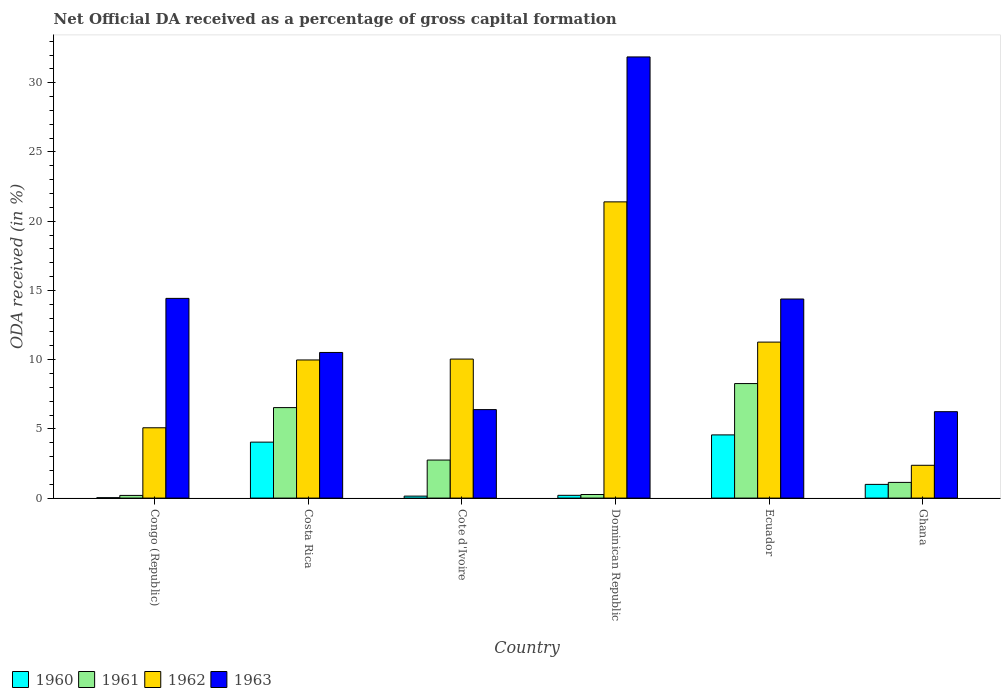Are the number of bars per tick equal to the number of legend labels?
Offer a terse response. Yes. What is the label of the 5th group of bars from the left?
Provide a succinct answer. Ecuador. What is the net ODA received in 1961 in Dominican Republic?
Ensure brevity in your answer.  0.26. Across all countries, what is the maximum net ODA received in 1963?
Provide a succinct answer. 31.86. Across all countries, what is the minimum net ODA received in 1963?
Give a very brief answer. 6.24. In which country was the net ODA received in 1960 maximum?
Your answer should be compact. Ecuador. What is the total net ODA received in 1963 in the graph?
Provide a succinct answer. 83.82. What is the difference between the net ODA received in 1963 in Congo (Republic) and that in Cote d'Ivoire?
Your answer should be very brief. 8.03. What is the difference between the net ODA received in 1960 in Ecuador and the net ODA received in 1963 in Cote d'Ivoire?
Offer a terse response. -1.83. What is the average net ODA received in 1963 per country?
Ensure brevity in your answer.  13.97. What is the difference between the net ODA received of/in 1961 and net ODA received of/in 1962 in Congo (Republic)?
Keep it short and to the point. -4.89. In how many countries, is the net ODA received in 1960 greater than 29 %?
Make the answer very short. 0. What is the ratio of the net ODA received in 1960 in Congo (Republic) to that in Ghana?
Your response must be concise. 0.03. Is the net ODA received in 1963 in Congo (Republic) less than that in Ecuador?
Offer a terse response. No. Is the difference between the net ODA received in 1961 in Congo (Republic) and Ghana greater than the difference between the net ODA received in 1962 in Congo (Republic) and Ghana?
Offer a terse response. No. What is the difference between the highest and the second highest net ODA received in 1962?
Your response must be concise. -1.23. What is the difference between the highest and the lowest net ODA received in 1963?
Offer a terse response. 25.62. Is the sum of the net ODA received in 1962 in Congo (Republic) and Cote d'Ivoire greater than the maximum net ODA received in 1961 across all countries?
Offer a very short reply. Yes. Is it the case that in every country, the sum of the net ODA received in 1962 and net ODA received in 1960 is greater than the sum of net ODA received in 1963 and net ODA received in 1961?
Offer a terse response. No. What does the 3rd bar from the left in Ecuador represents?
Offer a very short reply. 1962. How many bars are there?
Ensure brevity in your answer.  24. Are all the bars in the graph horizontal?
Provide a short and direct response. No. What is the difference between two consecutive major ticks on the Y-axis?
Your response must be concise. 5. Does the graph contain grids?
Make the answer very short. No. What is the title of the graph?
Give a very brief answer. Net Official DA received as a percentage of gross capital formation. Does "1981" appear as one of the legend labels in the graph?
Your response must be concise. No. What is the label or title of the Y-axis?
Give a very brief answer. ODA received (in %). What is the ODA received (in %) of 1960 in Congo (Republic)?
Keep it short and to the point. 0.03. What is the ODA received (in %) of 1961 in Congo (Republic)?
Make the answer very short. 0.19. What is the ODA received (in %) of 1962 in Congo (Republic)?
Ensure brevity in your answer.  5.08. What is the ODA received (in %) in 1963 in Congo (Republic)?
Your answer should be very brief. 14.43. What is the ODA received (in %) in 1960 in Costa Rica?
Provide a short and direct response. 4.04. What is the ODA received (in %) of 1961 in Costa Rica?
Your answer should be compact. 6.54. What is the ODA received (in %) of 1962 in Costa Rica?
Keep it short and to the point. 9.98. What is the ODA received (in %) of 1963 in Costa Rica?
Ensure brevity in your answer.  10.52. What is the ODA received (in %) of 1960 in Cote d'Ivoire?
Ensure brevity in your answer.  0.14. What is the ODA received (in %) in 1961 in Cote d'Ivoire?
Provide a short and direct response. 2.75. What is the ODA received (in %) in 1962 in Cote d'Ivoire?
Make the answer very short. 10.04. What is the ODA received (in %) in 1963 in Cote d'Ivoire?
Provide a succinct answer. 6.39. What is the ODA received (in %) of 1960 in Dominican Republic?
Your response must be concise. 0.2. What is the ODA received (in %) of 1961 in Dominican Republic?
Offer a terse response. 0.26. What is the ODA received (in %) in 1962 in Dominican Republic?
Ensure brevity in your answer.  21.4. What is the ODA received (in %) in 1963 in Dominican Republic?
Your answer should be compact. 31.86. What is the ODA received (in %) in 1960 in Ecuador?
Provide a succinct answer. 4.56. What is the ODA received (in %) in 1961 in Ecuador?
Give a very brief answer. 8.27. What is the ODA received (in %) of 1962 in Ecuador?
Your answer should be compact. 11.27. What is the ODA received (in %) in 1963 in Ecuador?
Your answer should be compact. 14.38. What is the ODA received (in %) in 1960 in Ghana?
Provide a short and direct response. 0.99. What is the ODA received (in %) in 1961 in Ghana?
Ensure brevity in your answer.  1.13. What is the ODA received (in %) in 1962 in Ghana?
Your response must be concise. 2.37. What is the ODA received (in %) of 1963 in Ghana?
Give a very brief answer. 6.24. Across all countries, what is the maximum ODA received (in %) of 1960?
Provide a short and direct response. 4.56. Across all countries, what is the maximum ODA received (in %) in 1961?
Offer a very short reply. 8.27. Across all countries, what is the maximum ODA received (in %) in 1962?
Provide a succinct answer. 21.4. Across all countries, what is the maximum ODA received (in %) of 1963?
Your response must be concise. 31.86. Across all countries, what is the minimum ODA received (in %) in 1960?
Provide a short and direct response. 0.03. Across all countries, what is the minimum ODA received (in %) in 1961?
Offer a very short reply. 0.19. Across all countries, what is the minimum ODA received (in %) of 1962?
Give a very brief answer. 2.37. Across all countries, what is the minimum ODA received (in %) of 1963?
Offer a terse response. 6.24. What is the total ODA received (in %) of 1960 in the graph?
Offer a terse response. 9.97. What is the total ODA received (in %) in 1961 in the graph?
Make the answer very short. 19.14. What is the total ODA received (in %) in 1962 in the graph?
Offer a very short reply. 60.13. What is the total ODA received (in %) of 1963 in the graph?
Your response must be concise. 83.82. What is the difference between the ODA received (in %) of 1960 in Congo (Republic) and that in Costa Rica?
Provide a succinct answer. -4.01. What is the difference between the ODA received (in %) in 1961 in Congo (Republic) and that in Costa Rica?
Provide a succinct answer. -6.34. What is the difference between the ODA received (in %) of 1962 in Congo (Republic) and that in Costa Rica?
Your response must be concise. -4.9. What is the difference between the ODA received (in %) of 1963 in Congo (Republic) and that in Costa Rica?
Keep it short and to the point. 3.91. What is the difference between the ODA received (in %) of 1960 in Congo (Republic) and that in Cote d'Ivoire?
Make the answer very short. -0.11. What is the difference between the ODA received (in %) of 1961 in Congo (Republic) and that in Cote d'Ivoire?
Offer a terse response. -2.55. What is the difference between the ODA received (in %) of 1962 in Congo (Republic) and that in Cote d'Ivoire?
Offer a terse response. -4.96. What is the difference between the ODA received (in %) of 1963 in Congo (Republic) and that in Cote d'Ivoire?
Offer a very short reply. 8.03. What is the difference between the ODA received (in %) of 1960 in Congo (Republic) and that in Dominican Republic?
Provide a succinct answer. -0.17. What is the difference between the ODA received (in %) of 1961 in Congo (Republic) and that in Dominican Republic?
Provide a succinct answer. -0.06. What is the difference between the ODA received (in %) in 1962 in Congo (Republic) and that in Dominican Republic?
Your answer should be compact. -16.32. What is the difference between the ODA received (in %) in 1963 in Congo (Republic) and that in Dominican Republic?
Provide a succinct answer. -17.44. What is the difference between the ODA received (in %) of 1960 in Congo (Republic) and that in Ecuador?
Your answer should be very brief. -4.54. What is the difference between the ODA received (in %) in 1961 in Congo (Republic) and that in Ecuador?
Your response must be concise. -8.08. What is the difference between the ODA received (in %) of 1962 in Congo (Republic) and that in Ecuador?
Give a very brief answer. -6.19. What is the difference between the ODA received (in %) in 1963 in Congo (Republic) and that in Ecuador?
Provide a short and direct response. 0.05. What is the difference between the ODA received (in %) in 1960 in Congo (Republic) and that in Ghana?
Make the answer very short. -0.96. What is the difference between the ODA received (in %) in 1961 in Congo (Republic) and that in Ghana?
Offer a terse response. -0.94. What is the difference between the ODA received (in %) of 1962 in Congo (Republic) and that in Ghana?
Provide a short and direct response. 2.71. What is the difference between the ODA received (in %) in 1963 in Congo (Republic) and that in Ghana?
Offer a very short reply. 8.18. What is the difference between the ODA received (in %) in 1960 in Costa Rica and that in Cote d'Ivoire?
Ensure brevity in your answer.  3.9. What is the difference between the ODA received (in %) of 1961 in Costa Rica and that in Cote d'Ivoire?
Provide a succinct answer. 3.79. What is the difference between the ODA received (in %) in 1962 in Costa Rica and that in Cote d'Ivoire?
Ensure brevity in your answer.  -0.06. What is the difference between the ODA received (in %) in 1963 in Costa Rica and that in Cote d'Ivoire?
Make the answer very short. 4.13. What is the difference between the ODA received (in %) in 1960 in Costa Rica and that in Dominican Republic?
Your answer should be very brief. 3.84. What is the difference between the ODA received (in %) of 1961 in Costa Rica and that in Dominican Republic?
Ensure brevity in your answer.  6.28. What is the difference between the ODA received (in %) of 1962 in Costa Rica and that in Dominican Republic?
Your answer should be compact. -11.42. What is the difference between the ODA received (in %) in 1963 in Costa Rica and that in Dominican Republic?
Provide a succinct answer. -21.35. What is the difference between the ODA received (in %) in 1960 in Costa Rica and that in Ecuador?
Provide a short and direct response. -0.52. What is the difference between the ODA received (in %) of 1961 in Costa Rica and that in Ecuador?
Provide a short and direct response. -1.74. What is the difference between the ODA received (in %) in 1962 in Costa Rica and that in Ecuador?
Keep it short and to the point. -1.29. What is the difference between the ODA received (in %) in 1963 in Costa Rica and that in Ecuador?
Your response must be concise. -3.86. What is the difference between the ODA received (in %) of 1960 in Costa Rica and that in Ghana?
Keep it short and to the point. 3.05. What is the difference between the ODA received (in %) in 1961 in Costa Rica and that in Ghana?
Ensure brevity in your answer.  5.4. What is the difference between the ODA received (in %) in 1962 in Costa Rica and that in Ghana?
Your answer should be very brief. 7.61. What is the difference between the ODA received (in %) of 1963 in Costa Rica and that in Ghana?
Keep it short and to the point. 4.28. What is the difference between the ODA received (in %) in 1960 in Cote d'Ivoire and that in Dominican Republic?
Offer a terse response. -0.06. What is the difference between the ODA received (in %) in 1961 in Cote d'Ivoire and that in Dominican Republic?
Provide a succinct answer. 2.49. What is the difference between the ODA received (in %) in 1962 in Cote d'Ivoire and that in Dominican Republic?
Offer a very short reply. -11.35. What is the difference between the ODA received (in %) of 1963 in Cote d'Ivoire and that in Dominican Republic?
Provide a succinct answer. -25.47. What is the difference between the ODA received (in %) of 1960 in Cote d'Ivoire and that in Ecuador?
Provide a succinct answer. -4.42. What is the difference between the ODA received (in %) of 1961 in Cote d'Ivoire and that in Ecuador?
Your response must be concise. -5.52. What is the difference between the ODA received (in %) in 1962 in Cote d'Ivoire and that in Ecuador?
Provide a succinct answer. -1.23. What is the difference between the ODA received (in %) of 1963 in Cote d'Ivoire and that in Ecuador?
Ensure brevity in your answer.  -7.99. What is the difference between the ODA received (in %) in 1960 in Cote d'Ivoire and that in Ghana?
Ensure brevity in your answer.  -0.85. What is the difference between the ODA received (in %) in 1961 in Cote d'Ivoire and that in Ghana?
Make the answer very short. 1.61. What is the difference between the ODA received (in %) in 1962 in Cote d'Ivoire and that in Ghana?
Your response must be concise. 7.67. What is the difference between the ODA received (in %) of 1963 in Cote d'Ivoire and that in Ghana?
Your answer should be compact. 0.15. What is the difference between the ODA received (in %) of 1960 in Dominican Republic and that in Ecuador?
Give a very brief answer. -4.36. What is the difference between the ODA received (in %) in 1961 in Dominican Republic and that in Ecuador?
Provide a short and direct response. -8.01. What is the difference between the ODA received (in %) in 1962 in Dominican Republic and that in Ecuador?
Your answer should be compact. 10.13. What is the difference between the ODA received (in %) of 1963 in Dominican Republic and that in Ecuador?
Your answer should be compact. 17.49. What is the difference between the ODA received (in %) of 1960 in Dominican Republic and that in Ghana?
Your answer should be compact. -0.79. What is the difference between the ODA received (in %) in 1961 in Dominican Republic and that in Ghana?
Keep it short and to the point. -0.88. What is the difference between the ODA received (in %) in 1962 in Dominican Republic and that in Ghana?
Ensure brevity in your answer.  19.03. What is the difference between the ODA received (in %) in 1963 in Dominican Republic and that in Ghana?
Your answer should be compact. 25.62. What is the difference between the ODA received (in %) of 1960 in Ecuador and that in Ghana?
Offer a very short reply. 3.57. What is the difference between the ODA received (in %) of 1961 in Ecuador and that in Ghana?
Your response must be concise. 7.14. What is the difference between the ODA received (in %) of 1962 in Ecuador and that in Ghana?
Your response must be concise. 8.9. What is the difference between the ODA received (in %) of 1963 in Ecuador and that in Ghana?
Keep it short and to the point. 8.14. What is the difference between the ODA received (in %) in 1960 in Congo (Republic) and the ODA received (in %) in 1961 in Costa Rica?
Give a very brief answer. -6.51. What is the difference between the ODA received (in %) in 1960 in Congo (Republic) and the ODA received (in %) in 1962 in Costa Rica?
Offer a terse response. -9.95. What is the difference between the ODA received (in %) in 1960 in Congo (Republic) and the ODA received (in %) in 1963 in Costa Rica?
Ensure brevity in your answer.  -10.49. What is the difference between the ODA received (in %) in 1961 in Congo (Republic) and the ODA received (in %) in 1962 in Costa Rica?
Ensure brevity in your answer.  -9.78. What is the difference between the ODA received (in %) of 1961 in Congo (Republic) and the ODA received (in %) of 1963 in Costa Rica?
Offer a terse response. -10.32. What is the difference between the ODA received (in %) of 1962 in Congo (Republic) and the ODA received (in %) of 1963 in Costa Rica?
Your answer should be very brief. -5.44. What is the difference between the ODA received (in %) of 1960 in Congo (Republic) and the ODA received (in %) of 1961 in Cote d'Ivoire?
Your response must be concise. -2.72. What is the difference between the ODA received (in %) in 1960 in Congo (Republic) and the ODA received (in %) in 1962 in Cote d'Ivoire?
Make the answer very short. -10.01. What is the difference between the ODA received (in %) of 1960 in Congo (Republic) and the ODA received (in %) of 1963 in Cote d'Ivoire?
Give a very brief answer. -6.36. What is the difference between the ODA received (in %) in 1961 in Congo (Republic) and the ODA received (in %) in 1962 in Cote d'Ivoire?
Ensure brevity in your answer.  -9.85. What is the difference between the ODA received (in %) in 1961 in Congo (Republic) and the ODA received (in %) in 1963 in Cote d'Ivoire?
Ensure brevity in your answer.  -6.2. What is the difference between the ODA received (in %) of 1962 in Congo (Republic) and the ODA received (in %) of 1963 in Cote d'Ivoire?
Provide a succinct answer. -1.31. What is the difference between the ODA received (in %) of 1960 in Congo (Republic) and the ODA received (in %) of 1961 in Dominican Republic?
Your answer should be compact. -0.23. What is the difference between the ODA received (in %) in 1960 in Congo (Republic) and the ODA received (in %) in 1962 in Dominican Republic?
Make the answer very short. -21.37. What is the difference between the ODA received (in %) of 1960 in Congo (Republic) and the ODA received (in %) of 1963 in Dominican Republic?
Make the answer very short. -31.84. What is the difference between the ODA received (in %) in 1961 in Congo (Republic) and the ODA received (in %) in 1962 in Dominican Republic?
Your answer should be very brief. -21.2. What is the difference between the ODA received (in %) of 1961 in Congo (Republic) and the ODA received (in %) of 1963 in Dominican Republic?
Make the answer very short. -31.67. What is the difference between the ODA received (in %) of 1962 in Congo (Republic) and the ODA received (in %) of 1963 in Dominican Republic?
Give a very brief answer. -26.79. What is the difference between the ODA received (in %) of 1960 in Congo (Republic) and the ODA received (in %) of 1961 in Ecuador?
Offer a terse response. -8.24. What is the difference between the ODA received (in %) of 1960 in Congo (Republic) and the ODA received (in %) of 1962 in Ecuador?
Provide a short and direct response. -11.24. What is the difference between the ODA received (in %) in 1960 in Congo (Republic) and the ODA received (in %) in 1963 in Ecuador?
Keep it short and to the point. -14.35. What is the difference between the ODA received (in %) of 1961 in Congo (Republic) and the ODA received (in %) of 1962 in Ecuador?
Ensure brevity in your answer.  -11.07. What is the difference between the ODA received (in %) of 1961 in Congo (Republic) and the ODA received (in %) of 1963 in Ecuador?
Ensure brevity in your answer.  -14.19. What is the difference between the ODA received (in %) in 1962 in Congo (Republic) and the ODA received (in %) in 1963 in Ecuador?
Offer a terse response. -9.3. What is the difference between the ODA received (in %) of 1960 in Congo (Republic) and the ODA received (in %) of 1961 in Ghana?
Your answer should be compact. -1.11. What is the difference between the ODA received (in %) in 1960 in Congo (Republic) and the ODA received (in %) in 1962 in Ghana?
Provide a succinct answer. -2.34. What is the difference between the ODA received (in %) in 1960 in Congo (Republic) and the ODA received (in %) in 1963 in Ghana?
Your answer should be compact. -6.21. What is the difference between the ODA received (in %) of 1961 in Congo (Republic) and the ODA received (in %) of 1962 in Ghana?
Give a very brief answer. -2.18. What is the difference between the ODA received (in %) of 1961 in Congo (Republic) and the ODA received (in %) of 1963 in Ghana?
Provide a succinct answer. -6.05. What is the difference between the ODA received (in %) of 1962 in Congo (Republic) and the ODA received (in %) of 1963 in Ghana?
Offer a terse response. -1.16. What is the difference between the ODA received (in %) in 1960 in Costa Rica and the ODA received (in %) in 1961 in Cote d'Ivoire?
Provide a succinct answer. 1.29. What is the difference between the ODA received (in %) of 1960 in Costa Rica and the ODA received (in %) of 1962 in Cote d'Ivoire?
Your response must be concise. -6. What is the difference between the ODA received (in %) in 1960 in Costa Rica and the ODA received (in %) in 1963 in Cote d'Ivoire?
Give a very brief answer. -2.35. What is the difference between the ODA received (in %) in 1961 in Costa Rica and the ODA received (in %) in 1962 in Cote d'Ivoire?
Your answer should be compact. -3.51. What is the difference between the ODA received (in %) of 1961 in Costa Rica and the ODA received (in %) of 1963 in Cote d'Ivoire?
Your answer should be very brief. 0.14. What is the difference between the ODA received (in %) in 1962 in Costa Rica and the ODA received (in %) in 1963 in Cote d'Ivoire?
Keep it short and to the point. 3.59. What is the difference between the ODA received (in %) of 1960 in Costa Rica and the ODA received (in %) of 1961 in Dominican Republic?
Your answer should be very brief. 3.78. What is the difference between the ODA received (in %) in 1960 in Costa Rica and the ODA received (in %) in 1962 in Dominican Republic?
Ensure brevity in your answer.  -17.35. What is the difference between the ODA received (in %) of 1960 in Costa Rica and the ODA received (in %) of 1963 in Dominican Republic?
Give a very brief answer. -27.82. What is the difference between the ODA received (in %) of 1961 in Costa Rica and the ODA received (in %) of 1962 in Dominican Republic?
Your response must be concise. -14.86. What is the difference between the ODA received (in %) of 1961 in Costa Rica and the ODA received (in %) of 1963 in Dominican Republic?
Make the answer very short. -25.33. What is the difference between the ODA received (in %) in 1962 in Costa Rica and the ODA received (in %) in 1963 in Dominican Republic?
Your answer should be compact. -21.89. What is the difference between the ODA received (in %) of 1960 in Costa Rica and the ODA received (in %) of 1961 in Ecuador?
Make the answer very short. -4.23. What is the difference between the ODA received (in %) in 1960 in Costa Rica and the ODA received (in %) in 1962 in Ecuador?
Your answer should be very brief. -7.23. What is the difference between the ODA received (in %) of 1960 in Costa Rica and the ODA received (in %) of 1963 in Ecuador?
Your response must be concise. -10.34. What is the difference between the ODA received (in %) in 1961 in Costa Rica and the ODA received (in %) in 1962 in Ecuador?
Give a very brief answer. -4.73. What is the difference between the ODA received (in %) in 1961 in Costa Rica and the ODA received (in %) in 1963 in Ecuador?
Make the answer very short. -7.84. What is the difference between the ODA received (in %) in 1962 in Costa Rica and the ODA received (in %) in 1963 in Ecuador?
Keep it short and to the point. -4.4. What is the difference between the ODA received (in %) in 1960 in Costa Rica and the ODA received (in %) in 1961 in Ghana?
Provide a succinct answer. 2.91. What is the difference between the ODA received (in %) of 1960 in Costa Rica and the ODA received (in %) of 1962 in Ghana?
Make the answer very short. 1.67. What is the difference between the ODA received (in %) of 1960 in Costa Rica and the ODA received (in %) of 1963 in Ghana?
Ensure brevity in your answer.  -2.2. What is the difference between the ODA received (in %) in 1961 in Costa Rica and the ODA received (in %) in 1962 in Ghana?
Keep it short and to the point. 4.17. What is the difference between the ODA received (in %) in 1961 in Costa Rica and the ODA received (in %) in 1963 in Ghana?
Your response must be concise. 0.29. What is the difference between the ODA received (in %) in 1962 in Costa Rica and the ODA received (in %) in 1963 in Ghana?
Provide a short and direct response. 3.74. What is the difference between the ODA received (in %) of 1960 in Cote d'Ivoire and the ODA received (in %) of 1961 in Dominican Republic?
Make the answer very short. -0.12. What is the difference between the ODA received (in %) in 1960 in Cote d'Ivoire and the ODA received (in %) in 1962 in Dominican Republic?
Keep it short and to the point. -21.25. What is the difference between the ODA received (in %) in 1960 in Cote d'Ivoire and the ODA received (in %) in 1963 in Dominican Republic?
Make the answer very short. -31.72. What is the difference between the ODA received (in %) of 1961 in Cote d'Ivoire and the ODA received (in %) of 1962 in Dominican Republic?
Keep it short and to the point. -18.65. What is the difference between the ODA received (in %) in 1961 in Cote d'Ivoire and the ODA received (in %) in 1963 in Dominican Republic?
Provide a short and direct response. -29.12. What is the difference between the ODA received (in %) of 1962 in Cote d'Ivoire and the ODA received (in %) of 1963 in Dominican Republic?
Your answer should be very brief. -21.82. What is the difference between the ODA received (in %) of 1960 in Cote d'Ivoire and the ODA received (in %) of 1961 in Ecuador?
Keep it short and to the point. -8.13. What is the difference between the ODA received (in %) of 1960 in Cote d'Ivoire and the ODA received (in %) of 1962 in Ecuador?
Your answer should be very brief. -11.12. What is the difference between the ODA received (in %) of 1960 in Cote d'Ivoire and the ODA received (in %) of 1963 in Ecuador?
Make the answer very short. -14.24. What is the difference between the ODA received (in %) in 1961 in Cote d'Ivoire and the ODA received (in %) in 1962 in Ecuador?
Your answer should be compact. -8.52. What is the difference between the ODA received (in %) of 1961 in Cote d'Ivoire and the ODA received (in %) of 1963 in Ecuador?
Your answer should be very brief. -11.63. What is the difference between the ODA received (in %) in 1962 in Cote d'Ivoire and the ODA received (in %) in 1963 in Ecuador?
Make the answer very short. -4.34. What is the difference between the ODA received (in %) of 1960 in Cote d'Ivoire and the ODA received (in %) of 1961 in Ghana?
Your response must be concise. -0.99. What is the difference between the ODA received (in %) of 1960 in Cote d'Ivoire and the ODA received (in %) of 1962 in Ghana?
Ensure brevity in your answer.  -2.23. What is the difference between the ODA received (in %) in 1960 in Cote d'Ivoire and the ODA received (in %) in 1963 in Ghana?
Make the answer very short. -6.1. What is the difference between the ODA received (in %) of 1961 in Cote d'Ivoire and the ODA received (in %) of 1962 in Ghana?
Your answer should be very brief. 0.38. What is the difference between the ODA received (in %) in 1961 in Cote d'Ivoire and the ODA received (in %) in 1963 in Ghana?
Provide a short and direct response. -3.49. What is the difference between the ODA received (in %) in 1960 in Dominican Republic and the ODA received (in %) in 1961 in Ecuador?
Ensure brevity in your answer.  -8.07. What is the difference between the ODA received (in %) of 1960 in Dominican Republic and the ODA received (in %) of 1962 in Ecuador?
Ensure brevity in your answer.  -11.07. What is the difference between the ODA received (in %) in 1960 in Dominican Republic and the ODA received (in %) in 1963 in Ecuador?
Ensure brevity in your answer.  -14.18. What is the difference between the ODA received (in %) of 1961 in Dominican Republic and the ODA received (in %) of 1962 in Ecuador?
Offer a terse response. -11.01. What is the difference between the ODA received (in %) in 1961 in Dominican Republic and the ODA received (in %) in 1963 in Ecuador?
Keep it short and to the point. -14.12. What is the difference between the ODA received (in %) of 1962 in Dominican Republic and the ODA received (in %) of 1963 in Ecuador?
Give a very brief answer. 7.02. What is the difference between the ODA received (in %) in 1960 in Dominican Republic and the ODA received (in %) in 1961 in Ghana?
Offer a terse response. -0.93. What is the difference between the ODA received (in %) of 1960 in Dominican Republic and the ODA received (in %) of 1962 in Ghana?
Keep it short and to the point. -2.17. What is the difference between the ODA received (in %) in 1960 in Dominican Republic and the ODA received (in %) in 1963 in Ghana?
Give a very brief answer. -6.04. What is the difference between the ODA received (in %) of 1961 in Dominican Republic and the ODA received (in %) of 1962 in Ghana?
Give a very brief answer. -2.11. What is the difference between the ODA received (in %) of 1961 in Dominican Republic and the ODA received (in %) of 1963 in Ghana?
Offer a very short reply. -5.98. What is the difference between the ODA received (in %) in 1962 in Dominican Republic and the ODA received (in %) in 1963 in Ghana?
Ensure brevity in your answer.  15.15. What is the difference between the ODA received (in %) of 1960 in Ecuador and the ODA received (in %) of 1961 in Ghana?
Your answer should be very brief. 3.43. What is the difference between the ODA received (in %) of 1960 in Ecuador and the ODA received (in %) of 1962 in Ghana?
Make the answer very short. 2.19. What is the difference between the ODA received (in %) of 1960 in Ecuador and the ODA received (in %) of 1963 in Ghana?
Ensure brevity in your answer.  -1.68. What is the difference between the ODA received (in %) in 1961 in Ecuador and the ODA received (in %) in 1962 in Ghana?
Provide a short and direct response. 5.9. What is the difference between the ODA received (in %) in 1961 in Ecuador and the ODA received (in %) in 1963 in Ghana?
Your answer should be compact. 2.03. What is the difference between the ODA received (in %) in 1962 in Ecuador and the ODA received (in %) in 1963 in Ghana?
Your response must be concise. 5.03. What is the average ODA received (in %) of 1960 per country?
Offer a terse response. 1.66. What is the average ODA received (in %) of 1961 per country?
Offer a terse response. 3.19. What is the average ODA received (in %) of 1962 per country?
Ensure brevity in your answer.  10.02. What is the average ODA received (in %) in 1963 per country?
Your answer should be compact. 13.97. What is the difference between the ODA received (in %) of 1960 and ODA received (in %) of 1961 in Congo (Republic)?
Your answer should be compact. -0.17. What is the difference between the ODA received (in %) of 1960 and ODA received (in %) of 1962 in Congo (Republic)?
Offer a very short reply. -5.05. What is the difference between the ODA received (in %) of 1960 and ODA received (in %) of 1963 in Congo (Republic)?
Make the answer very short. -14.4. What is the difference between the ODA received (in %) of 1961 and ODA received (in %) of 1962 in Congo (Republic)?
Offer a very short reply. -4.89. What is the difference between the ODA received (in %) in 1961 and ODA received (in %) in 1963 in Congo (Republic)?
Ensure brevity in your answer.  -14.23. What is the difference between the ODA received (in %) in 1962 and ODA received (in %) in 1963 in Congo (Republic)?
Ensure brevity in your answer.  -9.35. What is the difference between the ODA received (in %) in 1960 and ODA received (in %) in 1961 in Costa Rica?
Your response must be concise. -2.49. What is the difference between the ODA received (in %) of 1960 and ODA received (in %) of 1962 in Costa Rica?
Give a very brief answer. -5.93. What is the difference between the ODA received (in %) in 1960 and ODA received (in %) in 1963 in Costa Rica?
Provide a short and direct response. -6.48. What is the difference between the ODA received (in %) in 1961 and ODA received (in %) in 1962 in Costa Rica?
Your response must be concise. -3.44. What is the difference between the ODA received (in %) of 1961 and ODA received (in %) of 1963 in Costa Rica?
Provide a short and direct response. -3.98. What is the difference between the ODA received (in %) in 1962 and ODA received (in %) in 1963 in Costa Rica?
Provide a short and direct response. -0.54. What is the difference between the ODA received (in %) in 1960 and ODA received (in %) in 1961 in Cote d'Ivoire?
Offer a very short reply. -2.6. What is the difference between the ODA received (in %) in 1960 and ODA received (in %) in 1962 in Cote d'Ivoire?
Provide a succinct answer. -9.9. What is the difference between the ODA received (in %) of 1960 and ODA received (in %) of 1963 in Cote d'Ivoire?
Offer a terse response. -6.25. What is the difference between the ODA received (in %) of 1961 and ODA received (in %) of 1962 in Cote d'Ivoire?
Offer a terse response. -7.29. What is the difference between the ODA received (in %) of 1961 and ODA received (in %) of 1963 in Cote d'Ivoire?
Offer a terse response. -3.64. What is the difference between the ODA received (in %) in 1962 and ODA received (in %) in 1963 in Cote d'Ivoire?
Offer a very short reply. 3.65. What is the difference between the ODA received (in %) in 1960 and ODA received (in %) in 1961 in Dominican Republic?
Ensure brevity in your answer.  -0.06. What is the difference between the ODA received (in %) in 1960 and ODA received (in %) in 1962 in Dominican Republic?
Your response must be concise. -21.2. What is the difference between the ODA received (in %) of 1960 and ODA received (in %) of 1963 in Dominican Republic?
Offer a terse response. -31.66. What is the difference between the ODA received (in %) of 1961 and ODA received (in %) of 1962 in Dominican Republic?
Give a very brief answer. -21.14. What is the difference between the ODA received (in %) of 1961 and ODA received (in %) of 1963 in Dominican Republic?
Your answer should be very brief. -31.61. What is the difference between the ODA received (in %) of 1962 and ODA received (in %) of 1963 in Dominican Republic?
Offer a terse response. -10.47. What is the difference between the ODA received (in %) in 1960 and ODA received (in %) in 1961 in Ecuador?
Offer a very short reply. -3.71. What is the difference between the ODA received (in %) in 1960 and ODA received (in %) in 1962 in Ecuador?
Keep it short and to the point. -6.7. What is the difference between the ODA received (in %) of 1960 and ODA received (in %) of 1963 in Ecuador?
Your response must be concise. -9.81. What is the difference between the ODA received (in %) in 1961 and ODA received (in %) in 1962 in Ecuador?
Provide a short and direct response. -3. What is the difference between the ODA received (in %) of 1961 and ODA received (in %) of 1963 in Ecuador?
Make the answer very short. -6.11. What is the difference between the ODA received (in %) in 1962 and ODA received (in %) in 1963 in Ecuador?
Provide a short and direct response. -3.11. What is the difference between the ODA received (in %) in 1960 and ODA received (in %) in 1961 in Ghana?
Keep it short and to the point. -0.14. What is the difference between the ODA received (in %) in 1960 and ODA received (in %) in 1962 in Ghana?
Your answer should be compact. -1.38. What is the difference between the ODA received (in %) in 1960 and ODA received (in %) in 1963 in Ghana?
Keep it short and to the point. -5.25. What is the difference between the ODA received (in %) in 1961 and ODA received (in %) in 1962 in Ghana?
Your answer should be compact. -1.24. What is the difference between the ODA received (in %) in 1961 and ODA received (in %) in 1963 in Ghana?
Make the answer very short. -5.11. What is the difference between the ODA received (in %) in 1962 and ODA received (in %) in 1963 in Ghana?
Your response must be concise. -3.87. What is the ratio of the ODA received (in %) of 1960 in Congo (Republic) to that in Costa Rica?
Offer a terse response. 0.01. What is the ratio of the ODA received (in %) in 1961 in Congo (Republic) to that in Costa Rica?
Your answer should be very brief. 0.03. What is the ratio of the ODA received (in %) of 1962 in Congo (Republic) to that in Costa Rica?
Give a very brief answer. 0.51. What is the ratio of the ODA received (in %) of 1963 in Congo (Republic) to that in Costa Rica?
Ensure brevity in your answer.  1.37. What is the ratio of the ODA received (in %) of 1960 in Congo (Republic) to that in Cote d'Ivoire?
Your answer should be very brief. 0.2. What is the ratio of the ODA received (in %) of 1961 in Congo (Republic) to that in Cote d'Ivoire?
Ensure brevity in your answer.  0.07. What is the ratio of the ODA received (in %) of 1962 in Congo (Republic) to that in Cote d'Ivoire?
Your response must be concise. 0.51. What is the ratio of the ODA received (in %) in 1963 in Congo (Republic) to that in Cote d'Ivoire?
Make the answer very short. 2.26. What is the ratio of the ODA received (in %) of 1960 in Congo (Republic) to that in Dominican Republic?
Keep it short and to the point. 0.14. What is the ratio of the ODA received (in %) of 1961 in Congo (Republic) to that in Dominican Republic?
Provide a short and direct response. 0.75. What is the ratio of the ODA received (in %) in 1962 in Congo (Republic) to that in Dominican Republic?
Make the answer very short. 0.24. What is the ratio of the ODA received (in %) of 1963 in Congo (Republic) to that in Dominican Republic?
Offer a terse response. 0.45. What is the ratio of the ODA received (in %) in 1960 in Congo (Republic) to that in Ecuador?
Offer a very short reply. 0.01. What is the ratio of the ODA received (in %) of 1961 in Congo (Republic) to that in Ecuador?
Keep it short and to the point. 0.02. What is the ratio of the ODA received (in %) in 1962 in Congo (Republic) to that in Ecuador?
Provide a succinct answer. 0.45. What is the ratio of the ODA received (in %) of 1963 in Congo (Republic) to that in Ecuador?
Make the answer very short. 1. What is the ratio of the ODA received (in %) in 1960 in Congo (Republic) to that in Ghana?
Offer a very short reply. 0.03. What is the ratio of the ODA received (in %) of 1961 in Congo (Republic) to that in Ghana?
Your answer should be compact. 0.17. What is the ratio of the ODA received (in %) of 1962 in Congo (Republic) to that in Ghana?
Make the answer very short. 2.14. What is the ratio of the ODA received (in %) in 1963 in Congo (Republic) to that in Ghana?
Provide a succinct answer. 2.31. What is the ratio of the ODA received (in %) in 1960 in Costa Rica to that in Cote d'Ivoire?
Your answer should be very brief. 28.4. What is the ratio of the ODA received (in %) of 1961 in Costa Rica to that in Cote d'Ivoire?
Your answer should be very brief. 2.38. What is the ratio of the ODA received (in %) in 1962 in Costa Rica to that in Cote d'Ivoire?
Keep it short and to the point. 0.99. What is the ratio of the ODA received (in %) in 1963 in Costa Rica to that in Cote d'Ivoire?
Provide a succinct answer. 1.65. What is the ratio of the ODA received (in %) of 1960 in Costa Rica to that in Dominican Republic?
Keep it short and to the point. 20.16. What is the ratio of the ODA received (in %) in 1961 in Costa Rica to that in Dominican Republic?
Ensure brevity in your answer.  25.27. What is the ratio of the ODA received (in %) in 1962 in Costa Rica to that in Dominican Republic?
Give a very brief answer. 0.47. What is the ratio of the ODA received (in %) of 1963 in Costa Rica to that in Dominican Republic?
Keep it short and to the point. 0.33. What is the ratio of the ODA received (in %) in 1960 in Costa Rica to that in Ecuador?
Offer a very short reply. 0.89. What is the ratio of the ODA received (in %) in 1961 in Costa Rica to that in Ecuador?
Offer a very short reply. 0.79. What is the ratio of the ODA received (in %) in 1962 in Costa Rica to that in Ecuador?
Provide a succinct answer. 0.89. What is the ratio of the ODA received (in %) of 1963 in Costa Rica to that in Ecuador?
Offer a very short reply. 0.73. What is the ratio of the ODA received (in %) in 1960 in Costa Rica to that in Ghana?
Provide a succinct answer. 4.08. What is the ratio of the ODA received (in %) of 1961 in Costa Rica to that in Ghana?
Your response must be concise. 5.76. What is the ratio of the ODA received (in %) of 1962 in Costa Rica to that in Ghana?
Your response must be concise. 4.21. What is the ratio of the ODA received (in %) in 1963 in Costa Rica to that in Ghana?
Your answer should be very brief. 1.69. What is the ratio of the ODA received (in %) of 1960 in Cote d'Ivoire to that in Dominican Republic?
Provide a succinct answer. 0.71. What is the ratio of the ODA received (in %) in 1961 in Cote d'Ivoire to that in Dominican Republic?
Offer a terse response. 10.62. What is the ratio of the ODA received (in %) of 1962 in Cote d'Ivoire to that in Dominican Republic?
Offer a terse response. 0.47. What is the ratio of the ODA received (in %) in 1963 in Cote d'Ivoire to that in Dominican Republic?
Provide a short and direct response. 0.2. What is the ratio of the ODA received (in %) of 1960 in Cote d'Ivoire to that in Ecuador?
Provide a succinct answer. 0.03. What is the ratio of the ODA received (in %) of 1961 in Cote d'Ivoire to that in Ecuador?
Make the answer very short. 0.33. What is the ratio of the ODA received (in %) in 1962 in Cote d'Ivoire to that in Ecuador?
Offer a terse response. 0.89. What is the ratio of the ODA received (in %) in 1963 in Cote d'Ivoire to that in Ecuador?
Your response must be concise. 0.44. What is the ratio of the ODA received (in %) of 1960 in Cote d'Ivoire to that in Ghana?
Ensure brevity in your answer.  0.14. What is the ratio of the ODA received (in %) in 1961 in Cote d'Ivoire to that in Ghana?
Give a very brief answer. 2.42. What is the ratio of the ODA received (in %) of 1962 in Cote d'Ivoire to that in Ghana?
Your answer should be compact. 4.24. What is the ratio of the ODA received (in %) of 1963 in Cote d'Ivoire to that in Ghana?
Your response must be concise. 1.02. What is the ratio of the ODA received (in %) of 1960 in Dominican Republic to that in Ecuador?
Your answer should be compact. 0.04. What is the ratio of the ODA received (in %) in 1961 in Dominican Republic to that in Ecuador?
Offer a very short reply. 0.03. What is the ratio of the ODA received (in %) of 1962 in Dominican Republic to that in Ecuador?
Your answer should be very brief. 1.9. What is the ratio of the ODA received (in %) of 1963 in Dominican Republic to that in Ecuador?
Offer a terse response. 2.22. What is the ratio of the ODA received (in %) of 1960 in Dominican Republic to that in Ghana?
Provide a short and direct response. 0.2. What is the ratio of the ODA received (in %) of 1961 in Dominican Republic to that in Ghana?
Your answer should be very brief. 0.23. What is the ratio of the ODA received (in %) of 1962 in Dominican Republic to that in Ghana?
Provide a succinct answer. 9.03. What is the ratio of the ODA received (in %) of 1963 in Dominican Republic to that in Ghana?
Offer a very short reply. 5.11. What is the ratio of the ODA received (in %) of 1960 in Ecuador to that in Ghana?
Your answer should be compact. 4.61. What is the ratio of the ODA received (in %) in 1961 in Ecuador to that in Ghana?
Your answer should be compact. 7.3. What is the ratio of the ODA received (in %) of 1962 in Ecuador to that in Ghana?
Provide a succinct answer. 4.75. What is the ratio of the ODA received (in %) of 1963 in Ecuador to that in Ghana?
Provide a short and direct response. 2.3. What is the difference between the highest and the second highest ODA received (in %) of 1960?
Your answer should be compact. 0.52. What is the difference between the highest and the second highest ODA received (in %) of 1961?
Your answer should be very brief. 1.74. What is the difference between the highest and the second highest ODA received (in %) in 1962?
Give a very brief answer. 10.13. What is the difference between the highest and the second highest ODA received (in %) in 1963?
Provide a succinct answer. 17.44. What is the difference between the highest and the lowest ODA received (in %) in 1960?
Provide a succinct answer. 4.54. What is the difference between the highest and the lowest ODA received (in %) in 1961?
Make the answer very short. 8.08. What is the difference between the highest and the lowest ODA received (in %) of 1962?
Give a very brief answer. 19.03. What is the difference between the highest and the lowest ODA received (in %) in 1963?
Provide a short and direct response. 25.62. 